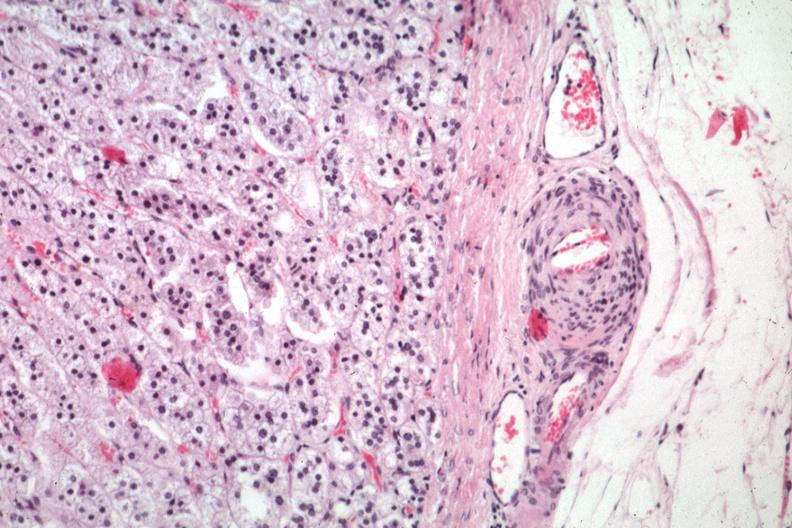where is this part in the figure?
Answer the question using a single word or phrase. Endocrine system 